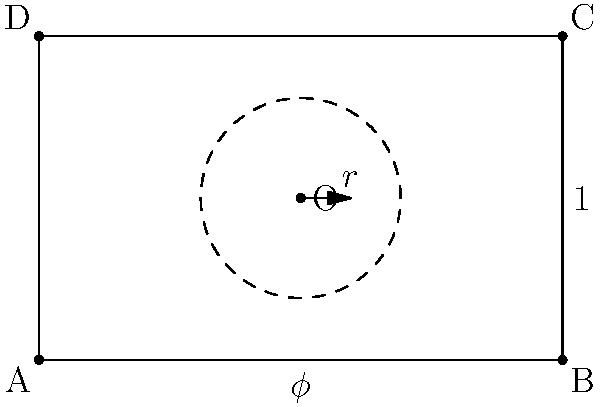Consider the rectangle ABCD, constructed using the golden ratio $\phi = \frac{1+\sqrt{5}}{2}$. An inscribed circle with center O touches all four sides of the rectangle. How might the trigonometric ratios in this figure relate to the perceived aesthetic appeal of architectural designs incorporating the golden ratio? Express the radius $r$ of the inscribed circle in terms of $\phi$ and explain its potential philosophical implications. 1) First, let's determine the radius $r$ of the inscribed circle:
   - The width of the rectangle is $\phi$ and the height is 1.
   - For a rectangle with width $w$ and height $h$, the radius of the inscribed circle is given by $r = \frac{wh}{w+h}$.
   - Substituting our values: $r = \frac{\phi \cdot 1}{\phi + 1} = \frac{\phi}{\phi + 1}$

2) We can simplify this further using the property of the golden ratio $\phi^2 = \phi + 1$:
   $r = \frac{\phi}{\phi + 1} = \frac{\phi}{\phi^2} = \frac{1}{\phi} = \frac{2}{\phi + 1}$

3) Now, let's consider the trigonometric implications:
   - The tangent of the angle between the diagonal and the long side is $\tan \theta = \frac{1}{\phi}$, which is equal to $r$.
   - This means that $r = \tan \theta = \frac{1}{\phi}$

4) Philosophical implications:
   - The golden ratio has been associated with aesthetic appeal in art and architecture for centuries.
   - The fact that the radius of the inscribed circle is directly related to a trigonometric function ($\tan \theta$) of the rectangle's proportions suggests a deep mathematical harmony.
   - This harmony might be perceived subconsciously, contributing to the sense of beauty and balance in designs using the golden ratio.
   - The relationship between $r$ and $\phi$ ($r = \frac{1}{\phi}$) represents a reciprocal balance, potentially symbolizing the interplay between part and whole in aesthetic perception.
   - The subjective experience of beauty might be influenced by these mathematical relationships, even if the viewer is not consciously aware of them.
   - This could support the philosophical argument that our subjective experiences (in this case, the perception of beauty) are shaped by underlying mathematical and geometric principles in the world around us.
Answer: $r = \frac{1}{\phi} = \tan \theta$, where $\theta$ is the angle between the diagonal and the long side of the golden rectangle. This relationship suggests that perceived beauty in architecture may be influenced by subconscious recognition of mathematical harmonies. 